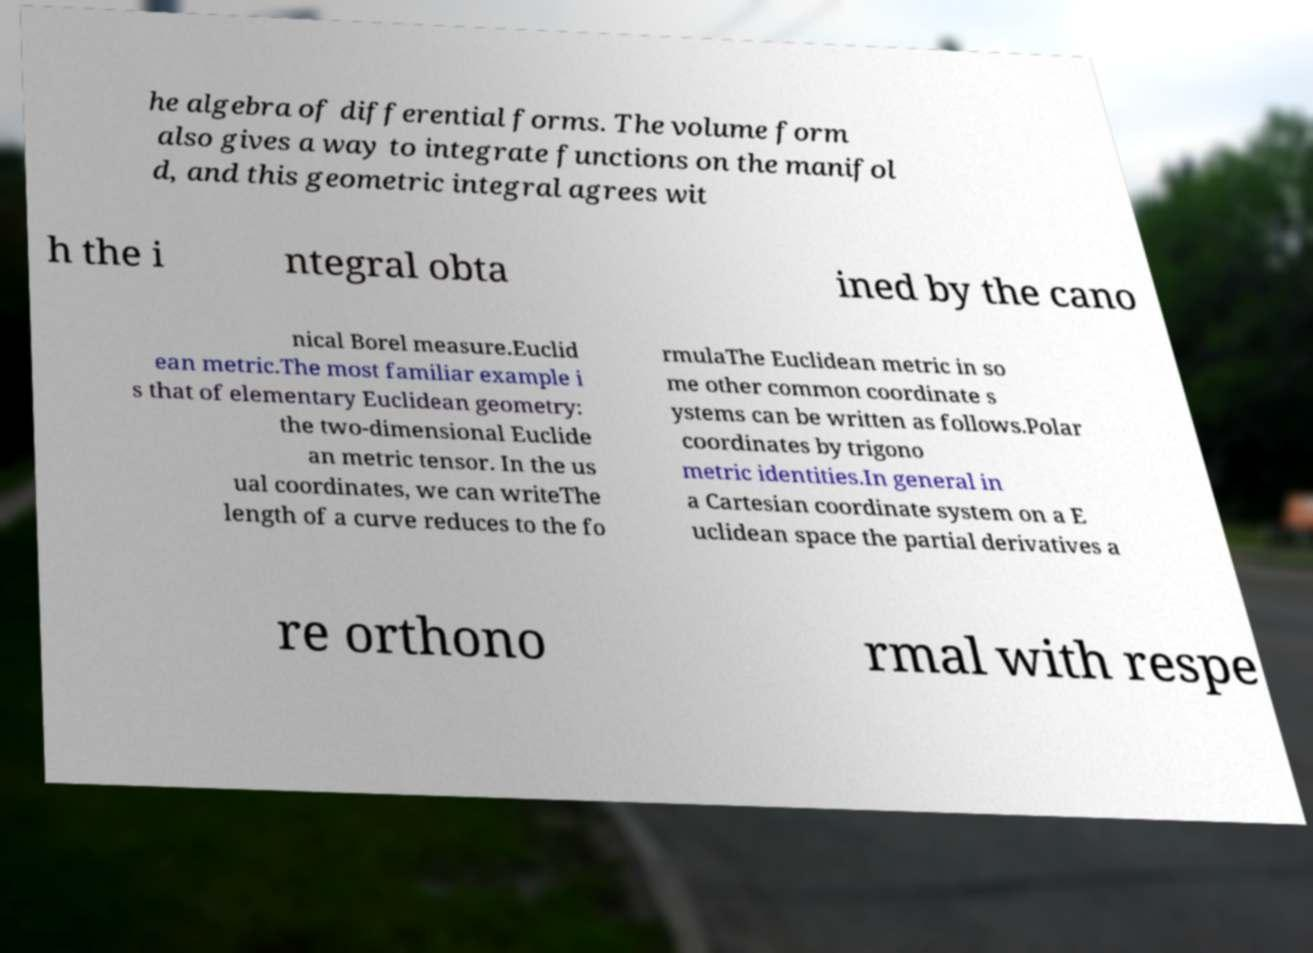What messages or text are displayed in this image? I need them in a readable, typed format. he algebra of differential forms. The volume form also gives a way to integrate functions on the manifol d, and this geometric integral agrees wit h the i ntegral obta ined by the cano nical Borel measure.Euclid ean metric.The most familiar example i s that of elementary Euclidean geometry: the two-dimensional Euclide an metric tensor. In the us ual coordinates, we can writeThe length of a curve reduces to the fo rmulaThe Euclidean metric in so me other common coordinate s ystems can be written as follows.Polar coordinates by trigono metric identities.In general in a Cartesian coordinate system on a E uclidean space the partial derivatives a re orthono rmal with respe 